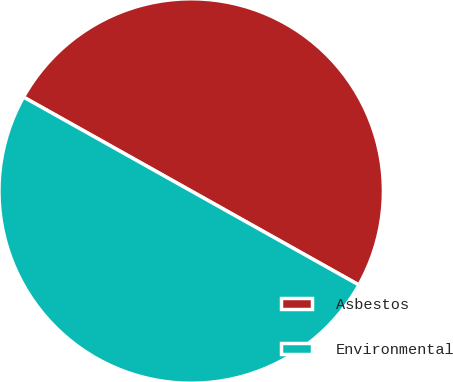Convert chart to OTSL. <chart><loc_0><loc_0><loc_500><loc_500><pie_chart><fcel>Asbestos<fcel>Environmental<nl><fcel>50.0%<fcel>50.0%<nl></chart> 